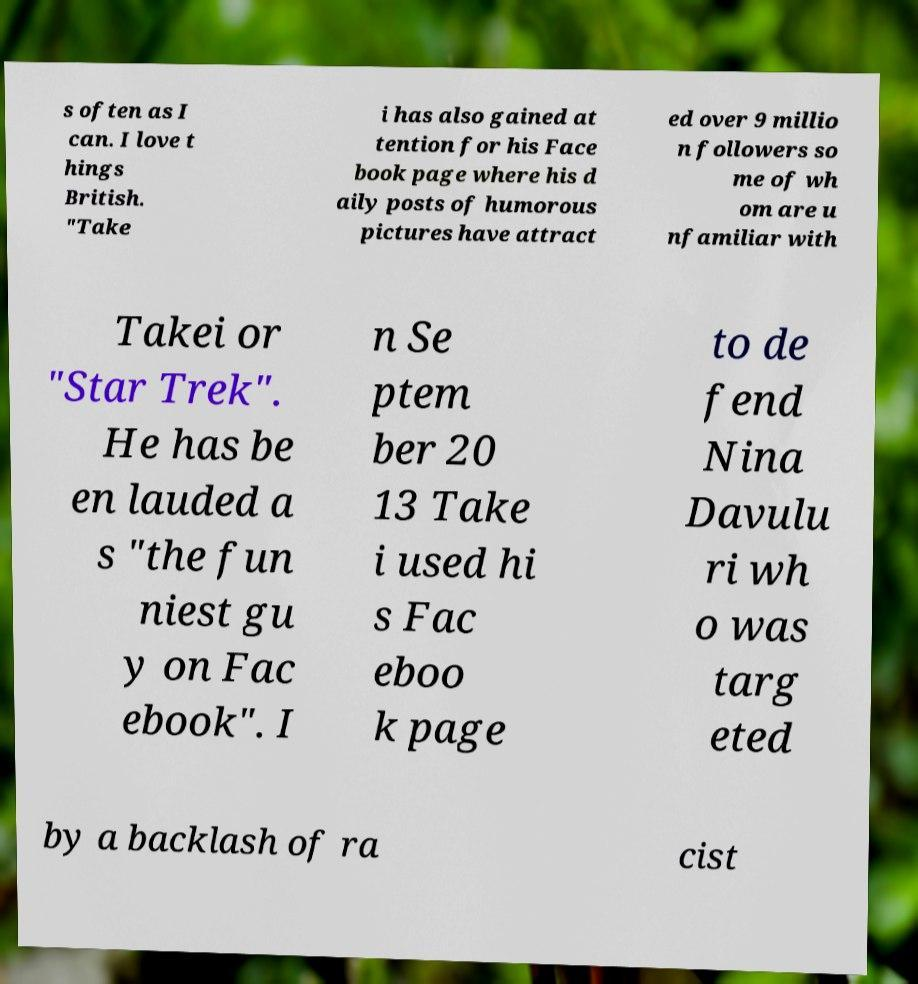Can you accurately transcribe the text from the provided image for me? s often as I can. I love t hings British. "Take i has also gained at tention for his Face book page where his d aily posts of humorous pictures have attract ed over 9 millio n followers so me of wh om are u nfamiliar with Takei or "Star Trek". He has be en lauded a s "the fun niest gu y on Fac ebook". I n Se ptem ber 20 13 Take i used hi s Fac eboo k page to de fend Nina Davulu ri wh o was targ eted by a backlash of ra cist 